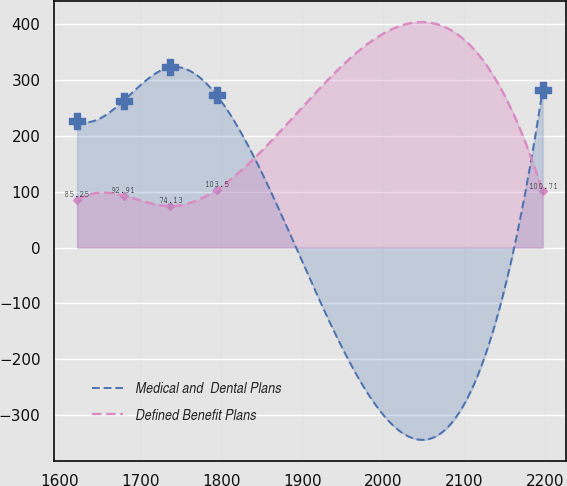Convert chart. <chart><loc_0><loc_0><loc_500><loc_500><line_chart><ecel><fcel>Medical and  Dental Plans<fcel>Defined Benefit Plans<nl><fcel>1621.81<fcel>227.15<fcel>85.25<nl><fcel>1679.3<fcel>262.98<fcel>92.91<nl><fcel>1736.79<fcel>322.63<fcel>74.13<nl><fcel>1794.28<fcel>272.53<fcel>103.5<nl><fcel>2196.74<fcel>282.08<fcel>100.71<nl></chart> 